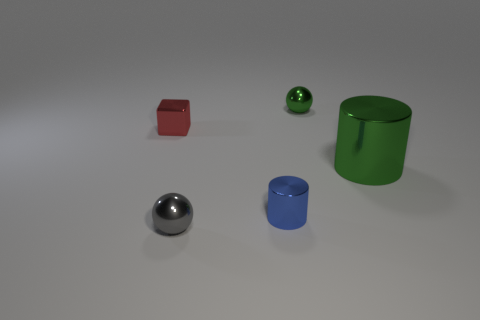Could you estimate the size of the objects in relation to each other? Based on the image, the green cylindrical object appears to be the tallest. The silver sphere and blue cylinder are similar in height but shorter than the green cylinder. The red cube is the smallest both in height and volume. 